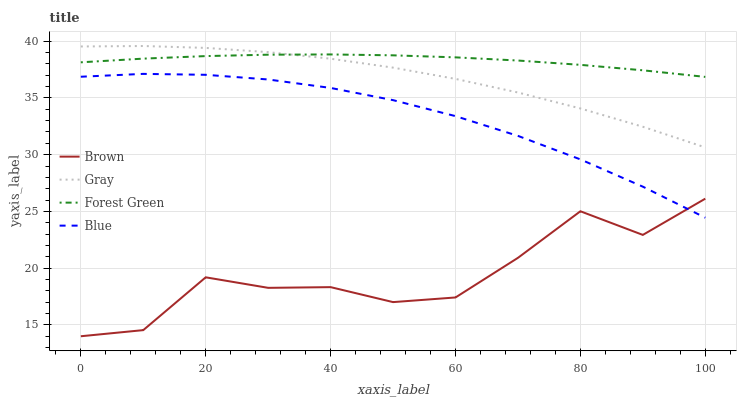Does Brown have the minimum area under the curve?
Answer yes or no. Yes. Does Forest Green have the maximum area under the curve?
Answer yes or no. Yes. Does Forest Green have the minimum area under the curve?
Answer yes or no. No. Does Brown have the maximum area under the curve?
Answer yes or no. No. Is Forest Green the smoothest?
Answer yes or no. Yes. Is Brown the roughest?
Answer yes or no. Yes. Is Brown the smoothest?
Answer yes or no. No. Is Forest Green the roughest?
Answer yes or no. No. Does Brown have the lowest value?
Answer yes or no. Yes. Does Forest Green have the lowest value?
Answer yes or no. No. Does Gray have the highest value?
Answer yes or no. Yes. Does Forest Green have the highest value?
Answer yes or no. No. Is Brown less than Forest Green?
Answer yes or no. Yes. Is Forest Green greater than Brown?
Answer yes or no. Yes. Does Gray intersect Forest Green?
Answer yes or no. Yes. Is Gray less than Forest Green?
Answer yes or no. No. Is Gray greater than Forest Green?
Answer yes or no. No. Does Brown intersect Forest Green?
Answer yes or no. No. 